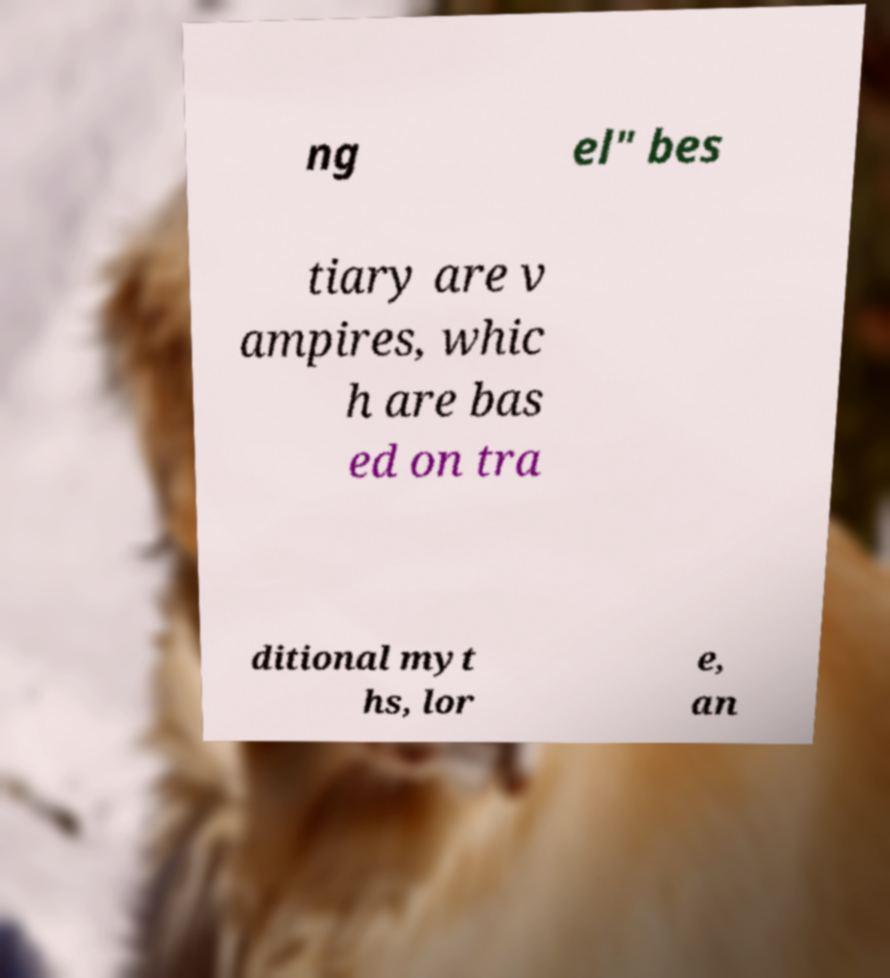Please identify and transcribe the text found in this image. ng el" bes tiary are v ampires, whic h are bas ed on tra ditional myt hs, lor e, an 